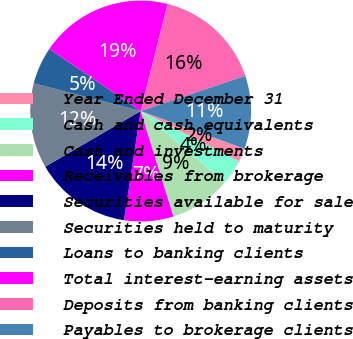<chart> <loc_0><loc_0><loc_500><loc_500><pie_chart><fcel>Year Ended December 31<fcel>Cash and cash equivalents<fcel>Cash and investments<fcel>Receivables from brokerage<fcel>Securities available for sale<fcel>Securities held to maturity<fcel>Loans to banking clients<fcel>Total interest-earning assets<fcel>Deposits from banking clients<fcel>Payables to brokerage clients<nl><fcel>1.98%<fcel>3.73%<fcel>8.95%<fcel>7.21%<fcel>14.18%<fcel>12.44%<fcel>5.47%<fcel>19.41%<fcel>15.92%<fcel>10.7%<nl></chart> 